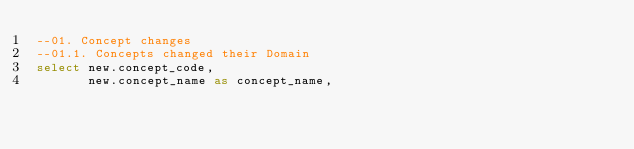<code> <loc_0><loc_0><loc_500><loc_500><_SQL_>--01. Concept changes
--01.1. Concepts changed their Domain
select new.concept_code,
       new.concept_name as concept_name,</code> 